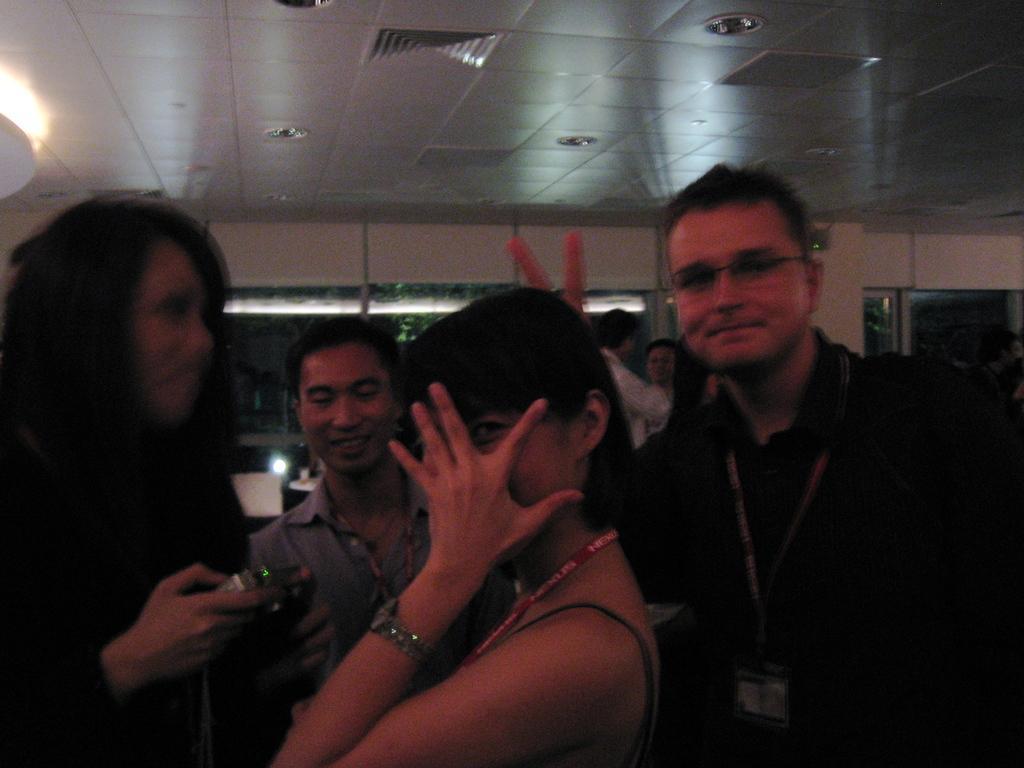How would you summarize this image in a sentence or two? In this picture there are four persons and the woman standing in the left corner is holding a camera in her hands and there are few other persons and some other objects in the background. 